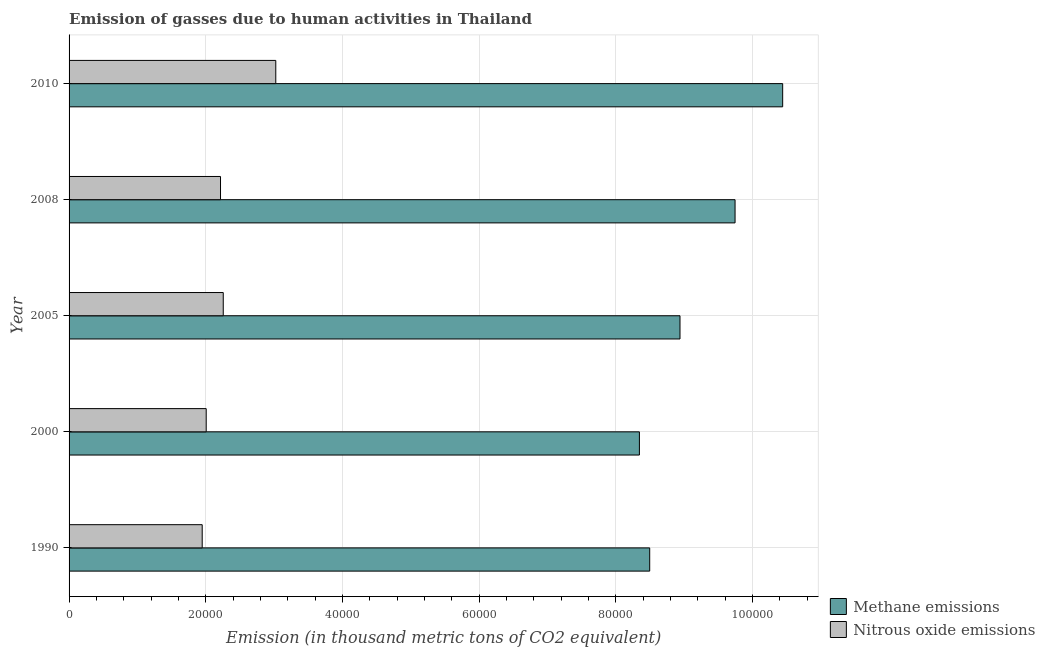How many bars are there on the 4th tick from the bottom?
Offer a terse response. 2. What is the amount of nitrous oxide emissions in 1990?
Your answer should be very brief. 1.95e+04. Across all years, what is the maximum amount of nitrous oxide emissions?
Provide a succinct answer. 3.02e+04. Across all years, what is the minimum amount of methane emissions?
Your answer should be compact. 8.34e+04. In which year was the amount of methane emissions minimum?
Give a very brief answer. 2000. What is the total amount of methane emissions in the graph?
Provide a short and direct response. 4.60e+05. What is the difference between the amount of nitrous oxide emissions in 2000 and that in 2010?
Make the answer very short. -1.02e+04. What is the difference between the amount of nitrous oxide emissions in 2005 and the amount of methane emissions in 1990?
Keep it short and to the point. -6.24e+04. What is the average amount of methane emissions per year?
Offer a terse response. 9.19e+04. In the year 1990, what is the difference between the amount of methane emissions and amount of nitrous oxide emissions?
Your answer should be compact. 6.55e+04. What is the ratio of the amount of methane emissions in 2000 to that in 2005?
Provide a succinct answer. 0.93. Is the difference between the amount of nitrous oxide emissions in 1990 and 2008 greater than the difference between the amount of methane emissions in 1990 and 2008?
Provide a succinct answer. Yes. What is the difference between the highest and the second highest amount of nitrous oxide emissions?
Provide a succinct answer. 7685.5. What is the difference between the highest and the lowest amount of nitrous oxide emissions?
Your answer should be very brief. 1.08e+04. In how many years, is the amount of nitrous oxide emissions greater than the average amount of nitrous oxide emissions taken over all years?
Make the answer very short. 1. Is the sum of the amount of nitrous oxide emissions in 2000 and 2005 greater than the maximum amount of methane emissions across all years?
Offer a terse response. No. What does the 1st bar from the top in 2008 represents?
Provide a short and direct response. Nitrous oxide emissions. What does the 2nd bar from the bottom in 2008 represents?
Make the answer very short. Nitrous oxide emissions. How many bars are there?
Provide a succinct answer. 10. Are all the bars in the graph horizontal?
Make the answer very short. Yes. How many years are there in the graph?
Provide a short and direct response. 5. What is the difference between two consecutive major ticks on the X-axis?
Provide a succinct answer. 2.00e+04. Are the values on the major ticks of X-axis written in scientific E-notation?
Make the answer very short. No. Does the graph contain any zero values?
Offer a terse response. No. Does the graph contain grids?
Your answer should be compact. Yes. Where does the legend appear in the graph?
Provide a short and direct response. Bottom right. How many legend labels are there?
Offer a very short reply. 2. What is the title of the graph?
Your answer should be very brief. Emission of gasses due to human activities in Thailand. What is the label or title of the X-axis?
Make the answer very short. Emission (in thousand metric tons of CO2 equivalent). What is the Emission (in thousand metric tons of CO2 equivalent) of Methane emissions in 1990?
Your answer should be compact. 8.50e+04. What is the Emission (in thousand metric tons of CO2 equivalent) of Nitrous oxide emissions in 1990?
Keep it short and to the point. 1.95e+04. What is the Emission (in thousand metric tons of CO2 equivalent) of Methane emissions in 2000?
Provide a short and direct response. 8.34e+04. What is the Emission (in thousand metric tons of CO2 equivalent) of Nitrous oxide emissions in 2000?
Provide a short and direct response. 2.01e+04. What is the Emission (in thousand metric tons of CO2 equivalent) of Methane emissions in 2005?
Ensure brevity in your answer.  8.94e+04. What is the Emission (in thousand metric tons of CO2 equivalent) of Nitrous oxide emissions in 2005?
Make the answer very short. 2.26e+04. What is the Emission (in thousand metric tons of CO2 equivalent) of Methane emissions in 2008?
Keep it short and to the point. 9.74e+04. What is the Emission (in thousand metric tons of CO2 equivalent) in Nitrous oxide emissions in 2008?
Make the answer very short. 2.22e+04. What is the Emission (in thousand metric tons of CO2 equivalent) in Methane emissions in 2010?
Ensure brevity in your answer.  1.04e+05. What is the Emission (in thousand metric tons of CO2 equivalent) of Nitrous oxide emissions in 2010?
Provide a succinct answer. 3.02e+04. Across all years, what is the maximum Emission (in thousand metric tons of CO2 equivalent) of Methane emissions?
Provide a short and direct response. 1.04e+05. Across all years, what is the maximum Emission (in thousand metric tons of CO2 equivalent) of Nitrous oxide emissions?
Give a very brief answer. 3.02e+04. Across all years, what is the minimum Emission (in thousand metric tons of CO2 equivalent) in Methane emissions?
Keep it short and to the point. 8.34e+04. Across all years, what is the minimum Emission (in thousand metric tons of CO2 equivalent) of Nitrous oxide emissions?
Your answer should be compact. 1.95e+04. What is the total Emission (in thousand metric tons of CO2 equivalent) of Methane emissions in the graph?
Ensure brevity in your answer.  4.60e+05. What is the total Emission (in thousand metric tons of CO2 equivalent) in Nitrous oxide emissions in the graph?
Provide a short and direct response. 1.15e+05. What is the difference between the Emission (in thousand metric tons of CO2 equivalent) in Methane emissions in 1990 and that in 2000?
Your response must be concise. 1507.2. What is the difference between the Emission (in thousand metric tons of CO2 equivalent) of Nitrous oxide emissions in 1990 and that in 2000?
Ensure brevity in your answer.  -586.2. What is the difference between the Emission (in thousand metric tons of CO2 equivalent) in Methane emissions in 1990 and that in 2005?
Your answer should be compact. -4432.2. What is the difference between the Emission (in thousand metric tons of CO2 equivalent) in Nitrous oxide emissions in 1990 and that in 2005?
Keep it short and to the point. -3080.2. What is the difference between the Emission (in thousand metric tons of CO2 equivalent) of Methane emissions in 1990 and that in 2008?
Give a very brief answer. -1.25e+04. What is the difference between the Emission (in thousand metric tons of CO2 equivalent) in Nitrous oxide emissions in 1990 and that in 2008?
Offer a very short reply. -2680.3. What is the difference between the Emission (in thousand metric tons of CO2 equivalent) of Methane emissions in 1990 and that in 2010?
Offer a very short reply. -1.95e+04. What is the difference between the Emission (in thousand metric tons of CO2 equivalent) of Nitrous oxide emissions in 1990 and that in 2010?
Ensure brevity in your answer.  -1.08e+04. What is the difference between the Emission (in thousand metric tons of CO2 equivalent) of Methane emissions in 2000 and that in 2005?
Your answer should be very brief. -5939.4. What is the difference between the Emission (in thousand metric tons of CO2 equivalent) in Nitrous oxide emissions in 2000 and that in 2005?
Keep it short and to the point. -2494. What is the difference between the Emission (in thousand metric tons of CO2 equivalent) of Methane emissions in 2000 and that in 2008?
Ensure brevity in your answer.  -1.40e+04. What is the difference between the Emission (in thousand metric tons of CO2 equivalent) in Nitrous oxide emissions in 2000 and that in 2008?
Your answer should be very brief. -2094.1. What is the difference between the Emission (in thousand metric tons of CO2 equivalent) of Methane emissions in 2000 and that in 2010?
Give a very brief answer. -2.10e+04. What is the difference between the Emission (in thousand metric tons of CO2 equivalent) of Nitrous oxide emissions in 2000 and that in 2010?
Make the answer very short. -1.02e+04. What is the difference between the Emission (in thousand metric tons of CO2 equivalent) of Methane emissions in 2005 and that in 2008?
Provide a succinct answer. -8056. What is the difference between the Emission (in thousand metric tons of CO2 equivalent) in Nitrous oxide emissions in 2005 and that in 2008?
Offer a very short reply. 399.9. What is the difference between the Emission (in thousand metric tons of CO2 equivalent) in Methane emissions in 2005 and that in 2010?
Your answer should be compact. -1.50e+04. What is the difference between the Emission (in thousand metric tons of CO2 equivalent) in Nitrous oxide emissions in 2005 and that in 2010?
Ensure brevity in your answer.  -7685.5. What is the difference between the Emission (in thousand metric tons of CO2 equivalent) of Methane emissions in 2008 and that in 2010?
Offer a terse response. -6966.7. What is the difference between the Emission (in thousand metric tons of CO2 equivalent) of Nitrous oxide emissions in 2008 and that in 2010?
Offer a terse response. -8085.4. What is the difference between the Emission (in thousand metric tons of CO2 equivalent) of Methane emissions in 1990 and the Emission (in thousand metric tons of CO2 equivalent) of Nitrous oxide emissions in 2000?
Ensure brevity in your answer.  6.49e+04. What is the difference between the Emission (in thousand metric tons of CO2 equivalent) of Methane emissions in 1990 and the Emission (in thousand metric tons of CO2 equivalent) of Nitrous oxide emissions in 2005?
Give a very brief answer. 6.24e+04. What is the difference between the Emission (in thousand metric tons of CO2 equivalent) in Methane emissions in 1990 and the Emission (in thousand metric tons of CO2 equivalent) in Nitrous oxide emissions in 2008?
Give a very brief answer. 6.28e+04. What is the difference between the Emission (in thousand metric tons of CO2 equivalent) in Methane emissions in 1990 and the Emission (in thousand metric tons of CO2 equivalent) in Nitrous oxide emissions in 2010?
Your answer should be compact. 5.47e+04. What is the difference between the Emission (in thousand metric tons of CO2 equivalent) of Methane emissions in 2000 and the Emission (in thousand metric tons of CO2 equivalent) of Nitrous oxide emissions in 2005?
Your response must be concise. 6.09e+04. What is the difference between the Emission (in thousand metric tons of CO2 equivalent) in Methane emissions in 2000 and the Emission (in thousand metric tons of CO2 equivalent) in Nitrous oxide emissions in 2008?
Offer a terse response. 6.13e+04. What is the difference between the Emission (in thousand metric tons of CO2 equivalent) in Methane emissions in 2000 and the Emission (in thousand metric tons of CO2 equivalent) in Nitrous oxide emissions in 2010?
Your answer should be compact. 5.32e+04. What is the difference between the Emission (in thousand metric tons of CO2 equivalent) of Methane emissions in 2005 and the Emission (in thousand metric tons of CO2 equivalent) of Nitrous oxide emissions in 2008?
Offer a very short reply. 6.72e+04. What is the difference between the Emission (in thousand metric tons of CO2 equivalent) in Methane emissions in 2005 and the Emission (in thousand metric tons of CO2 equivalent) in Nitrous oxide emissions in 2010?
Your answer should be very brief. 5.91e+04. What is the difference between the Emission (in thousand metric tons of CO2 equivalent) of Methane emissions in 2008 and the Emission (in thousand metric tons of CO2 equivalent) of Nitrous oxide emissions in 2010?
Ensure brevity in your answer.  6.72e+04. What is the average Emission (in thousand metric tons of CO2 equivalent) of Methane emissions per year?
Give a very brief answer. 9.19e+04. What is the average Emission (in thousand metric tons of CO2 equivalent) of Nitrous oxide emissions per year?
Offer a very short reply. 2.29e+04. In the year 1990, what is the difference between the Emission (in thousand metric tons of CO2 equivalent) in Methane emissions and Emission (in thousand metric tons of CO2 equivalent) in Nitrous oxide emissions?
Keep it short and to the point. 6.55e+04. In the year 2000, what is the difference between the Emission (in thousand metric tons of CO2 equivalent) in Methane emissions and Emission (in thousand metric tons of CO2 equivalent) in Nitrous oxide emissions?
Your answer should be very brief. 6.34e+04. In the year 2005, what is the difference between the Emission (in thousand metric tons of CO2 equivalent) of Methane emissions and Emission (in thousand metric tons of CO2 equivalent) of Nitrous oxide emissions?
Give a very brief answer. 6.68e+04. In the year 2008, what is the difference between the Emission (in thousand metric tons of CO2 equivalent) of Methane emissions and Emission (in thousand metric tons of CO2 equivalent) of Nitrous oxide emissions?
Provide a short and direct response. 7.53e+04. In the year 2010, what is the difference between the Emission (in thousand metric tons of CO2 equivalent) in Methane emissions and Emission (in thousand metric tons of CO2 equivalent) in Nitrous oxide emissions?
Keep it short and to the point. 7.42e+04. What is the ratio of the Emission (in thousand metric tons of CO2 equivalent) in Methane emissions in 1990 to that in 2000?
Ensure brevity in your answer.  1.02. What is the ratio of the Emission (in thousand metric tons of CO2 equivalent) in Nitrous oxide emissions in 1990 to that in 2000?
Your answer should be very brief. 0.97. What is the ratio of the Emission (in thousand metric tons of CO2 equivalent) of Methane emissions in 1990 to that in 2005?
Provide a short and direct response. 0.95. What is the ratio of the Emission (in thousand metric tons of CO2 equivalent) in Nitrous oxide emissions in 1990 to that in 2005?
Give a very brief answer. 0.86. What is the ratio of the Emission (in thousand metric tons of CO2 equivalent) of Methane emissions in 1990 to that in 2008?
Provide a succinct answer. 0.87. What is the ratio of the Emission (in thousand metric tons of CO2 equivalent) in Nitrous oxide emissions in 1990 to that in 2008?
Make the answer very short. 0.88. What is the ratio of the Emission (in thousand metric tons of CO2 equivalent) of Methane emissions in 1990 to that in 2010?
Provide a short and direct response. 0.81. What is the ratio of the Emission (in thousand metric tons of CO2 equivalent) in Nitrous oxide emissions in 1990 to that in 2010?
Offer a terse response. 0.64. What is the ratio of the Emission (in thousand metric tons of CO2 equivalent) in Methane emissions in 2000 to that in 2005?
Ensure brevity in your answer.  0.93. What is the ratio of the Emission (in thousand metric tons of CO2 equivalent) of Nitrous oxide emissions in 2000 to that in 2005?
Ensure brevity in your answer.  0.89. What is the ratio of the Emission (in thousand metric tons of CO2 equivalent) in Methane emissions in 2000 to that in 2008?
Your answer should be compact. 0.86. What is the ratio of the Emission (in thousand metric tons of CO2 equivalent) of Nitrous oxide emissions in 2000 to that in 2008?
Your response must be concise. 0.91. What is the ratio of the Emission (in thousand metric tons of CO2 equivalent) in Methane emissions in 2000 to that in 2010?
Make the answer very short. 0.8. What is the ratio of the Emission (in thousand metric tons of CO2 equivalent) of Nitrous oxide emissions in 2000 to that in 2010?
Your answer should be compact. 0.66. What is the ratio of the Emission (in thousand metric tons of CO2 equivalent) of Methane emissions in 2005 to that in 2008?
Make the answer very short. 0.92. What is the ratio of the Emission (in thousand metric tons of CO2 equivalent) in Nitrous oxide emissions in 2005 to that in 2008?
Offer a very short reply. 1.02. What is the ratio of the Emission (in thousand metric tons of CO2 equivalent) in Methane emissions in 2005 to that in 2010?
Your answer should be very brief. 0.86. What is the ratio of the Emission (in thousand metric tons of CO2 equivalent) in Nitrous oxide emissions in 2005 to that in 2010?
Give a very brief answer. 0.75. What is the ratio of the Emission (in thousand metric tons of CO2 equivalent) in Nitrous oxide emissions in 2008 to that in 2010?
Ensure brevity in your answer.  0.73. What is the difference between the highest and the second highest Emission (in thousand metric tons of CO2 equivalent) in Methane emissions?
Your answer should be compact. 6966.7. What is the difference between the highest and the second highest Emission (in thousand metric tons of CO2 equivalent) of Nitrous oxide emissions?
Your answer should be very brief. 7685.5. What is the difference between the highest and the lowest Emission (in thousand metric tons of CO2 equivalent) of Methane emissions?
Provide a short and direct response. 2.10e+04. What is the difference between the highest and the lowest Emission (in thousand metric tons of CO2 equivalent) of Nitrous oxide emissions?
Provide a succinct answer. 1.08e+04. 